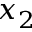Convert formula to latex. <formula><loc_0><loc_0><loc_500><loc_500>x _ { 2 }</formula> 